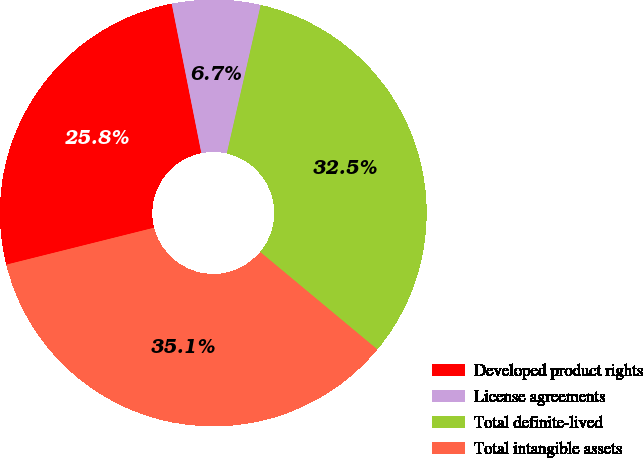Convert chart to OTSL. <chart><loc_0><loc_0><loc_500><loc_500><pie_chart><fcel>Developed product rights<fcel>License agreements<fcel>Total definite-lived<fcel>Total intangible assets<nl><fcel>25.78%<fcel>6.69%<fcel>32.47%<fcel>35.05%<nl></chart> 